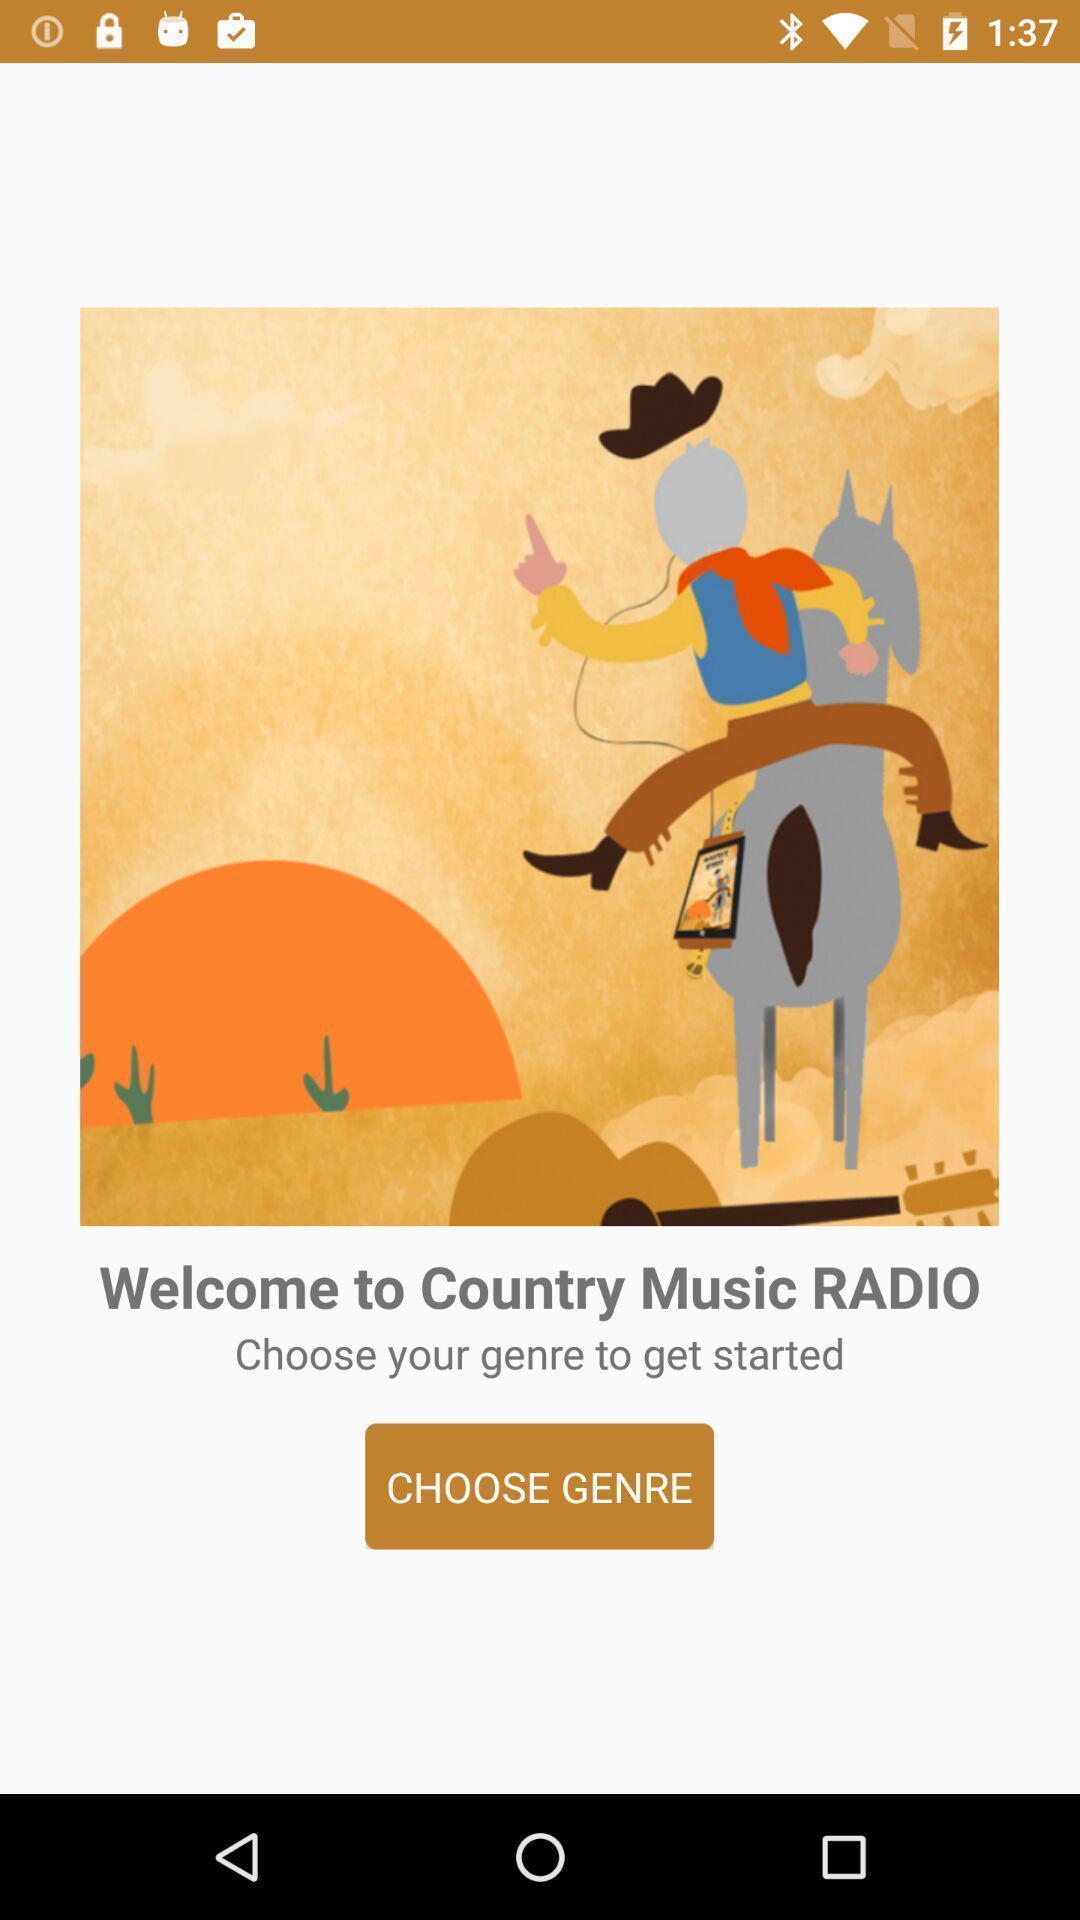What details can you identify in this image? Welcome page of social app. 